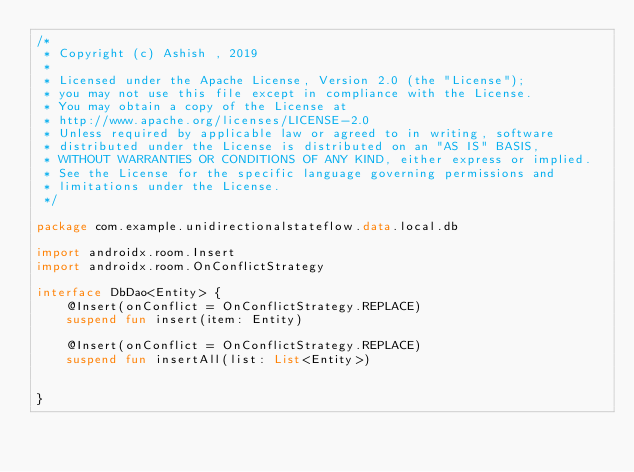Convert code to text. <code><loc_0><loc_0><loc_500><loc_500><_Kotlin_>/*
 * Copyright (c) Ashish , 2019
 *
 * Licensed under the Apache License, Version 2.0 (the "License");
 * you may not use this file except in compliance with the License.
 * You may obtain a copy of the License at
 * http://www.apache.org/licenses/LICENSE-2.0
 * Unless required by applicable law or agreed to in writing, software
 * distributed under the License is distributed on an "AS IS" BASIS,
 * WITHOUT WARRANTIES OR CONDITIONS OF ANY KIND, either express or implied.
 * See the License for the specific language governing permissions and
 * limitations under the License.
 */

package com.example.unidirectionalstateflow.data.local.db

import androidx.room.Insert
import androidx.room.OnConflictStrategy

interface DbDao<Entity> {
    @Insert(onConflict = OnConflictStrategy.REPLACE)
    suspend fun insert(item: Entity)

    @Insert(onConflict = OnConflictStrategy.REPLACE)
    suspend fun insertAll(list: List<Entity>)


}</code> 